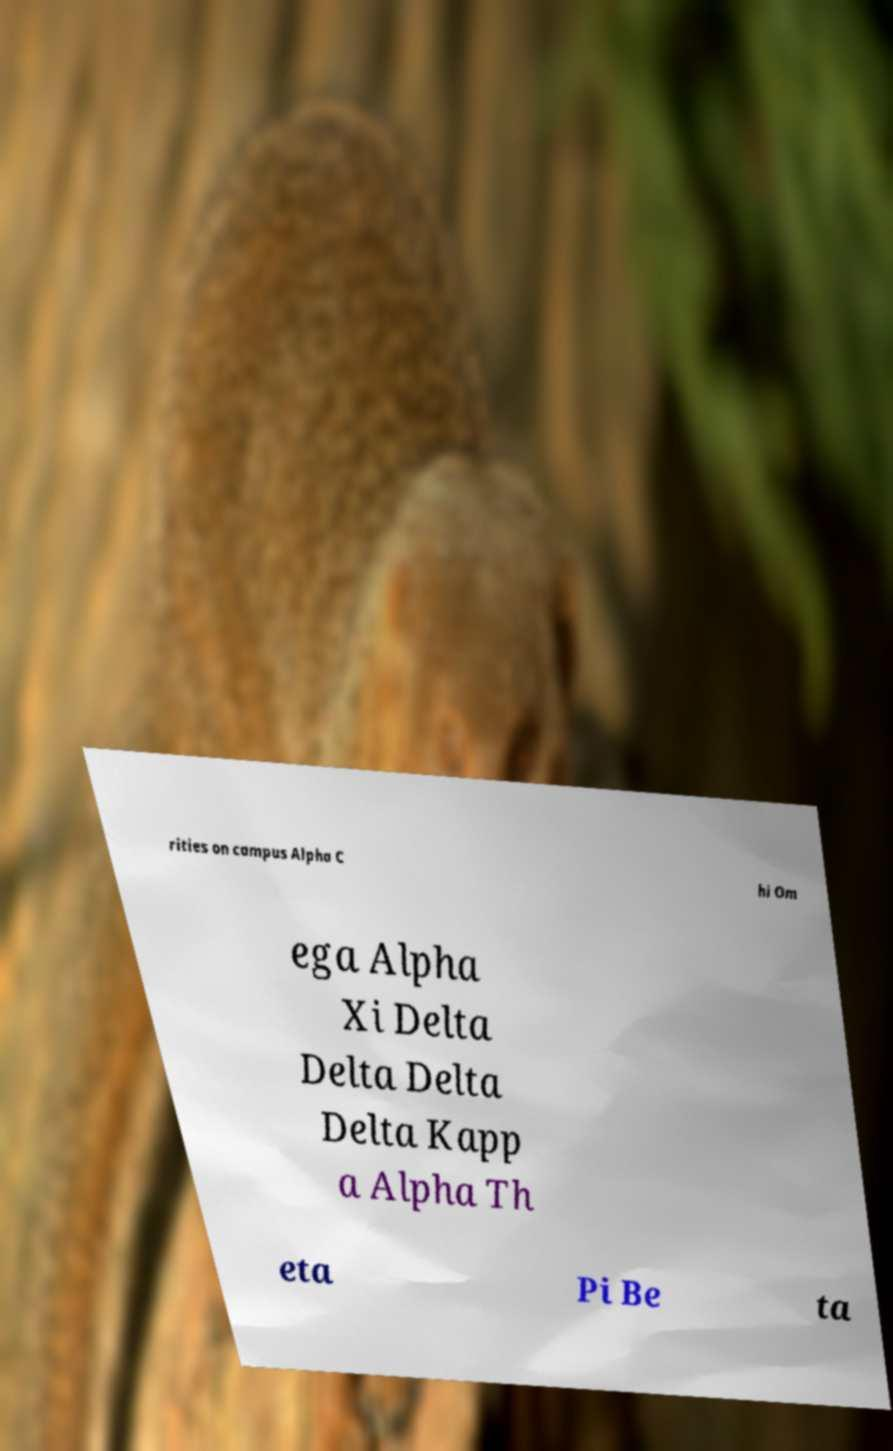I need the written content from this picture converted into text. Can you do that? rities on campus Alpha C hi Om ega Alpha Xi Delta Delta Delta Delta Kapp a Alpha Th eta Pi Be ta 